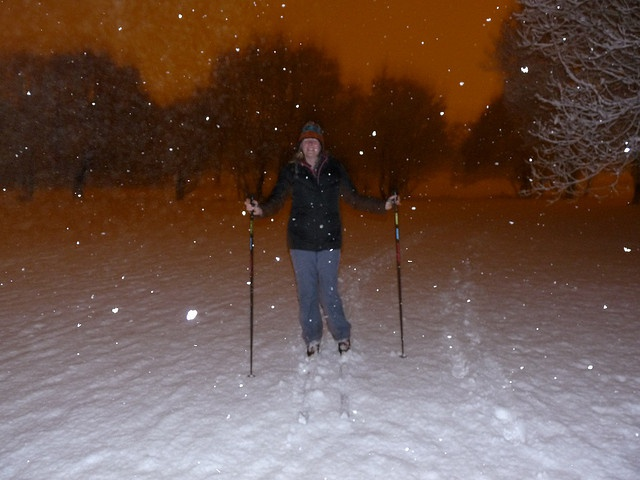Describe the objects in this image and their specific colors. I can see people in maroon, black, and gray tones and skis in maroon, darkgray, lavender, and lightgray tones in this image. 